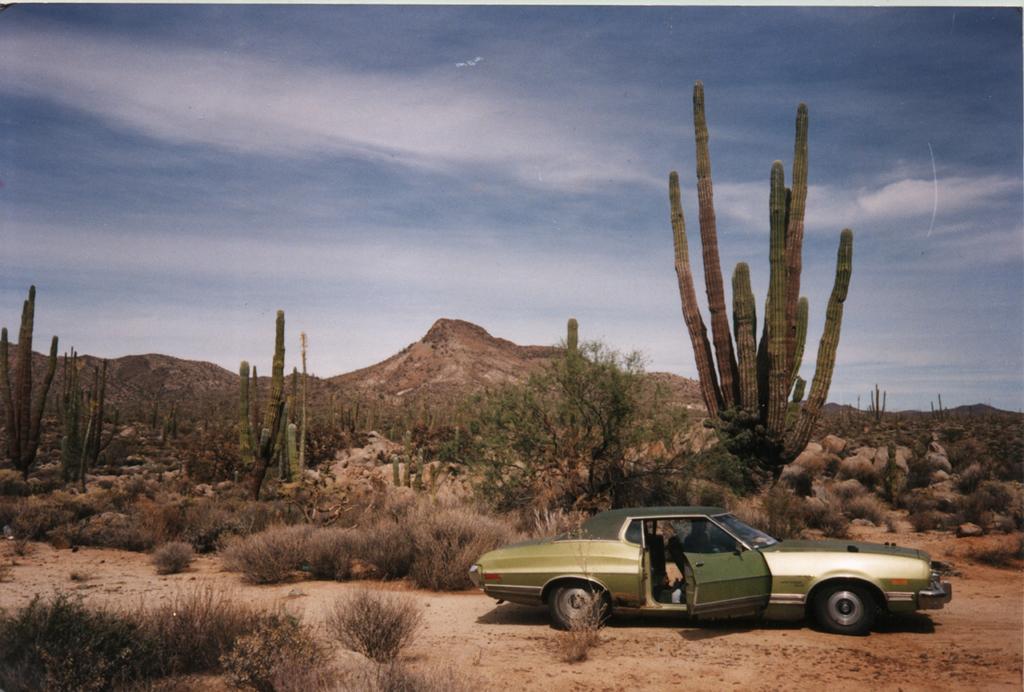Could you give a brief overview of what you see in this image? In this image I can see a vehicle on the ground. In the background, I can see the grass, trees. I can also see the hills and clouds in the sky. 